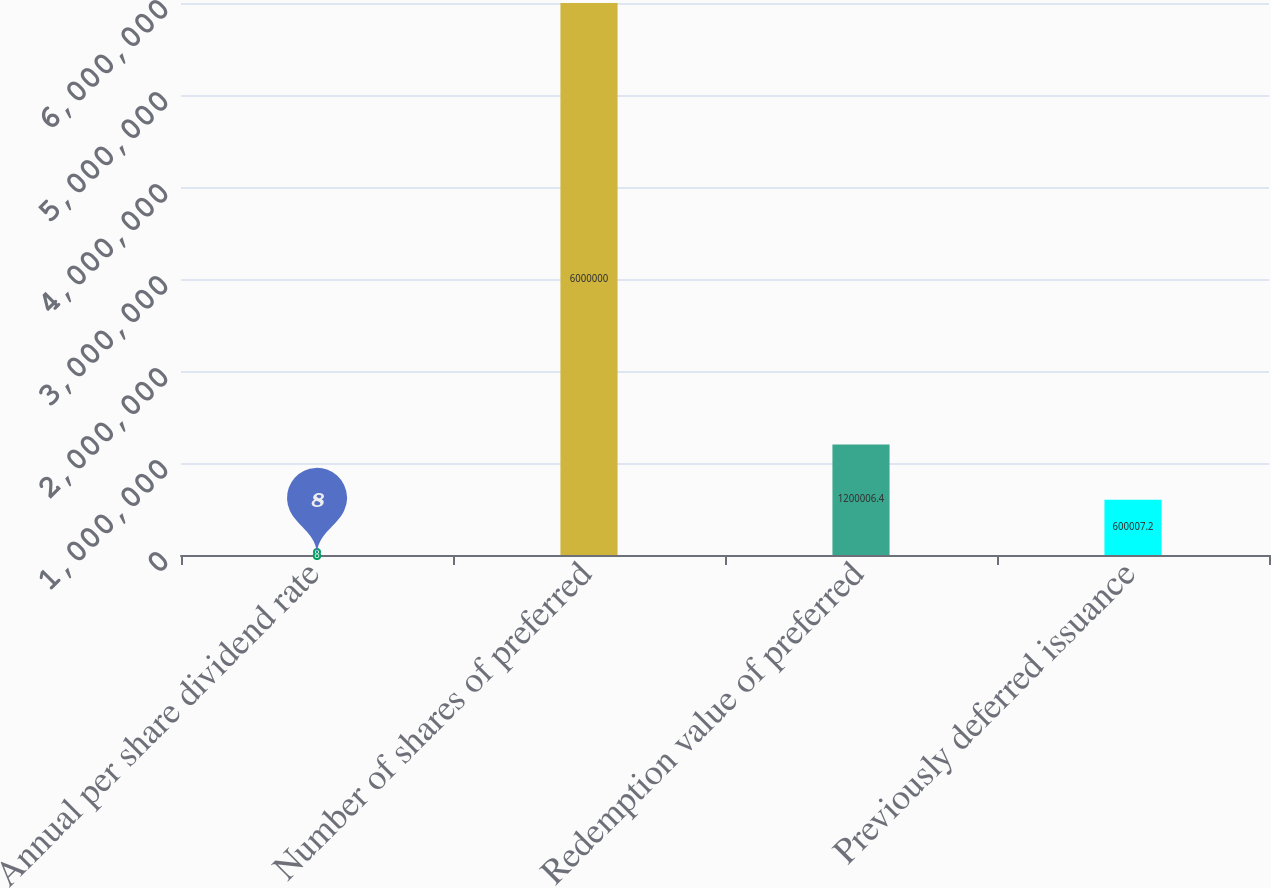Convert chart. <chart><loc_0><loc_0><loc_500><loc_500><bar_chart><fcel>Annual per share dividend rate<fcel>Number of shares of preferred<fcel>Redemption value of preferred<fcel>Previously deferred issuance<nl><fcel>8<fcel>6e+06<fcel>1.20001e+06<fcel>600007<nl></chart> 